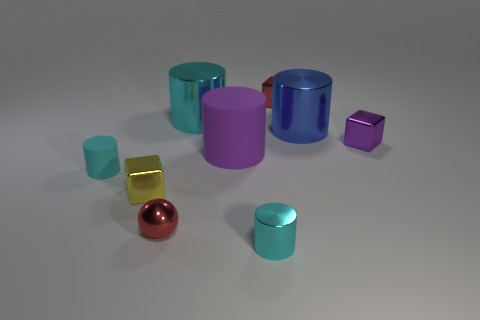What is the shape of the red object that is in front of the cyan object that is to the left of the metallic block in front of the purple shiny cube?
Keep it short and to the point. Sphere. What color is the matte object that is the same size as the blue metal object?
Provide a succinct answer. Purple. How many yellow objects are the same shape as the tiny cyan shiny thing?
Provide a short and direct response. 0. Is the size of the purple metal block the same as the red metal thing that is to the left of the big purple rubber cylinder?
Provide a succinct answer. Yes. The tiny red metallic thing to the left of the big metal object left of the big blue cylinder is what shape?
Your answer should be compact. Sphere. Are there fewer matte objects that are behind the purple block than cyan shiny cylinders?
Provide a short and direct response. Yes. There is a metallic object that is the same color as the tiny shiny cylinder; what is its shape?
Make the answer very short. Cylinder. What number of matte objects are the same size as the red shiny sphere?
Your answer should be compact. 1. What is the shape of the tiny red object in front of the tiny matte object?
Offer a terse response. Sphere. Are there fewer purple cubes than shiny things?
Make the answer very short. Yes. 